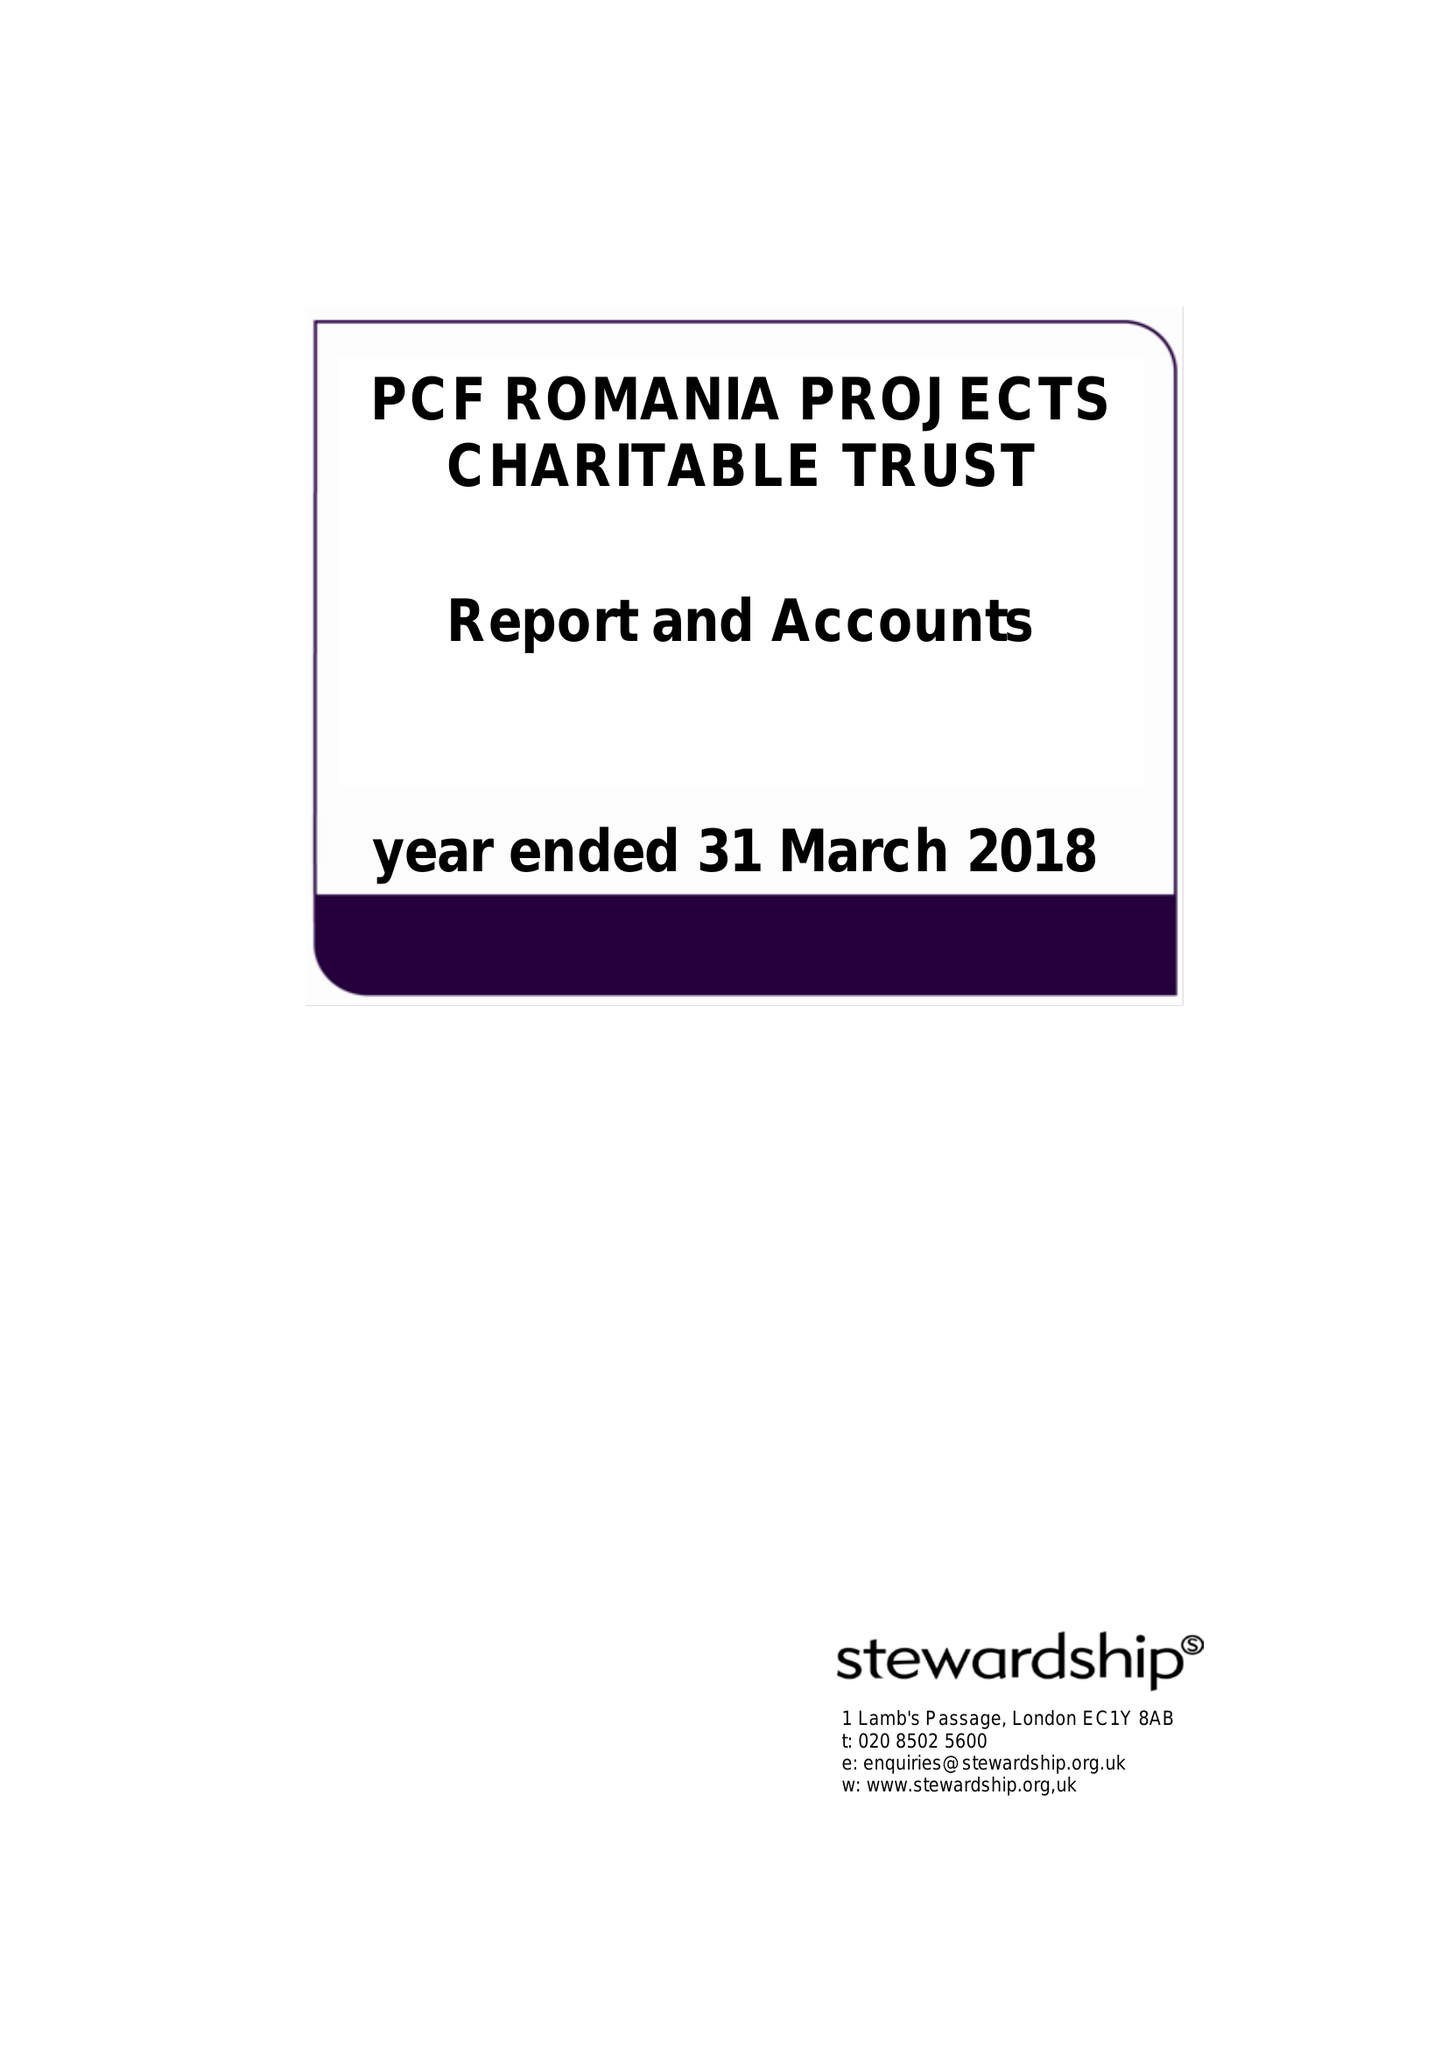What is the value for the address__postcode?
Answer the question using a single word or phrase. WV6 7UP 